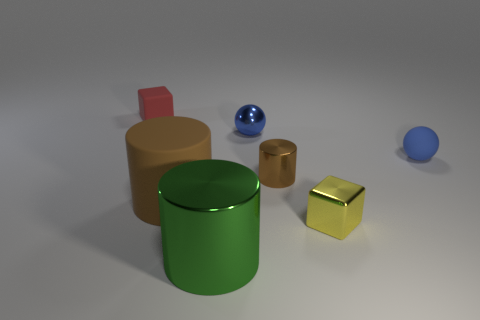Subtract all shiny cylinders. How many cylinders are left? 1 Add 2 large gray blocks. How many objects exist? 9 Add 6 blue metallic things. How many blue metallic things exist? 7 Subtract all red blocks. How many blocks are left? 1 Subtract 0 blue cylinders. How many objects are left? 7 Subtract all cylinders. How many objects are left? 4 Subtract 2 cylinders. How many cylinders are left? 1 Subtract all blue cylinders. Subtract all cyan blocks. How many cylinders are left? 3 Subtract all gray cubes. How many green cylinders are left? 1 Subtract all tiny yellow metallic blocks. Subtract all small yellow metal cubes. How many objects are left? 5 